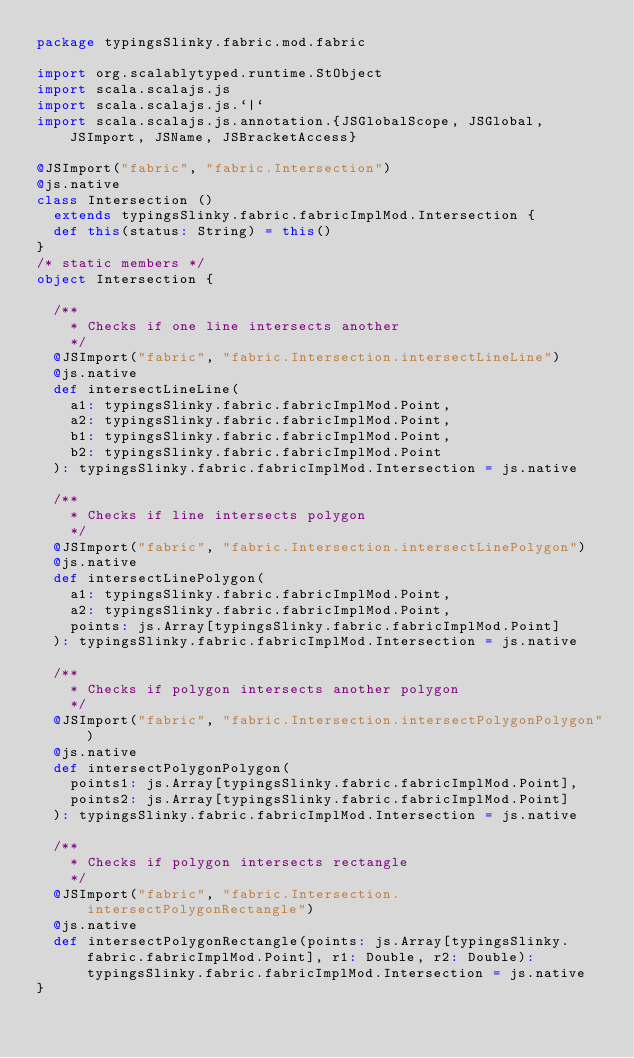<code> <loc_0><loc_0><loc_500><loc_500><_Scala_>package typingsSlinky.fabric.mod.fabric

import org.scalablytyped.runtime.StObject
import scala.scalajs.js
import scala.scalajs.js.`|`
import scala.scalajs.js.annotation.{JSGlobalScope, JSGlobal, JSImport, JSName, JSBracketAccess}

@JSImport("fabric", "fabric.Intersection")
@js.native
class Intersection ()
  extends typingsSlinky.fabric.fabricImplMod.Intersection {
  def this(status: String) = this()
}
/* static members */
object Intersection {
  
  /**
    * Checks if one line intersects another
    */
  @JSImport("fabric", "fabric.Intersection.intersectLineLine")
  @js.native
  def intersectLineLine(
    a1: typingsSlinky.fabric.fabricImplMod.Point,
    a2: typingsSlinky.fabric.fabricImplMod.Point,
    b1: typingsSlinky.fabric.fabricImplMod.Point,
    b2: typingsSlinky.fabric.fabricImplMod.Point
  ): typingsSlinky.fabric.fabricImplMod.Intersection = js.native
  
  /**
    * Checks if line intersects polygon
    */
  @JSImport("fabric", "fabric.Intersection.intersectLinePolygon")
  @js.native
  def intersectLinePolygon(
    a1: typingsSlinky.fabric.fabricImplMod.Point,
    a2: typingsSlinky.fabric.fabricImplMod.Point,
    points: js.Array[typingsSlinky.fabric.fabricImplMod.Point]
  ): typingsSlinky.fabric.fabricImplMod.Intersection = js.native
  
  /**
    * Checks if polygon intersects another polygon
    */
  @JSImport("fabric", "fabric.Intersection.intersectPolygonPolygon")
  @js.native
  def intersectPolygonPolygon(
    points1: js.Array[typingsSlinky.fabric.fabricImplMod.Point],
    points2: js.Array[typingsSlinky.fabric.fabricImplMod.Point]
  ): typingsSlinky.fabric.fabricImplMod.Intersection = js.native
  
  /**
    * Checks if polygon intersects rectangle
    */
  @JSImport("fabric", "fabric.Intersection.intersectPolygonRectangle")
  @js.native
  def intersectPolygonRectangle(points: js.Array[typingsSlinky.fabric.fabricImplMod.Point], r1: Double, r2: Double): typingsSlinky.fabric.fabricImplMod.Intersection = js.native
}
</code> 